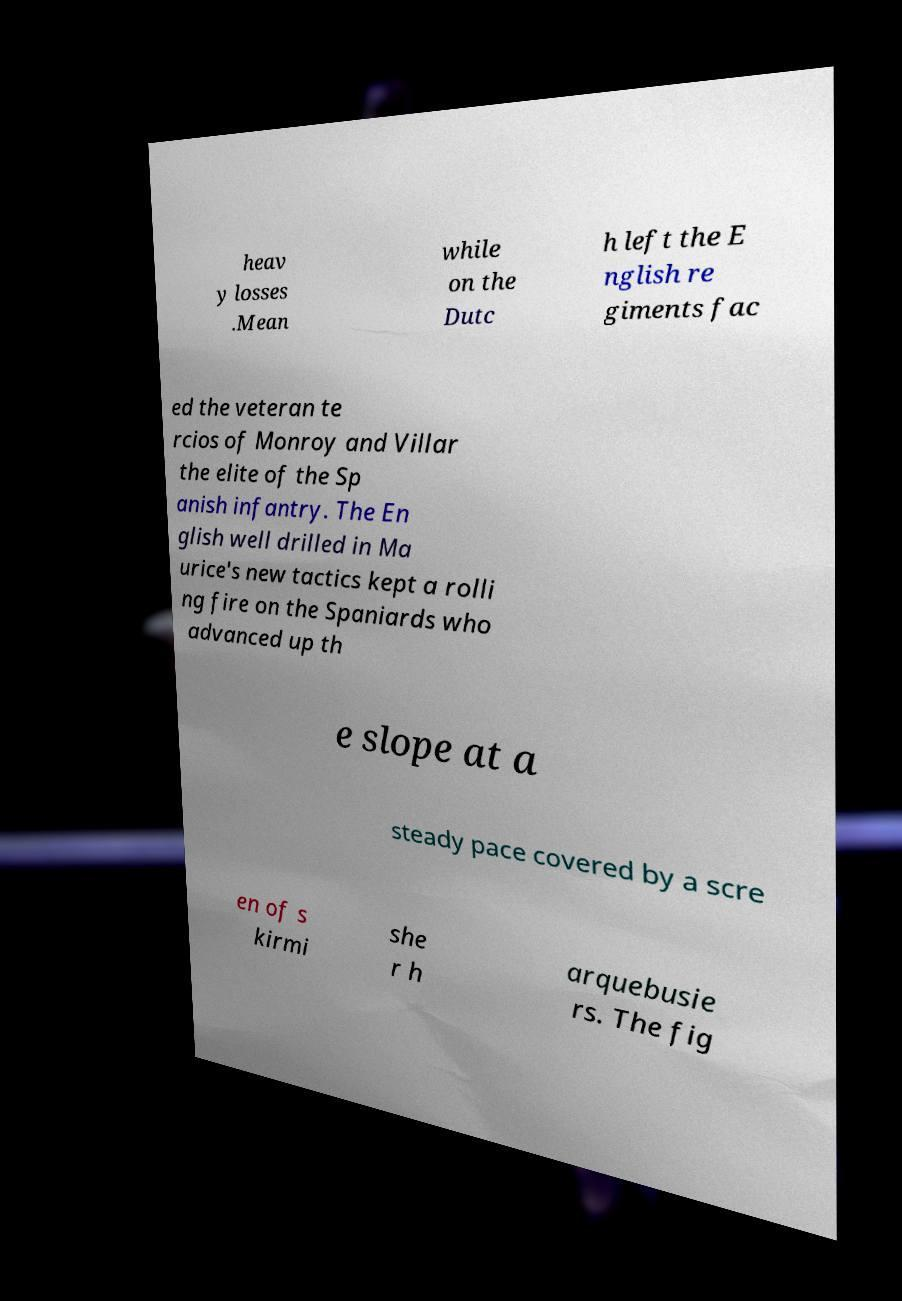Please identify and transcribe the text found in this image. heav y losses .Mean while on the Dutc h left the E nglish re giments fac ed the veteran te rcios of Monroy and Villar the elite of the Sp anish infantry. The En glish well drilled in Ma urice's new tactics kept a rolli ng fire on the Spaniards who advanced up th e slope at a steady pace covered by a scre en of s kirmi she r h arquebusie rs. The fig 